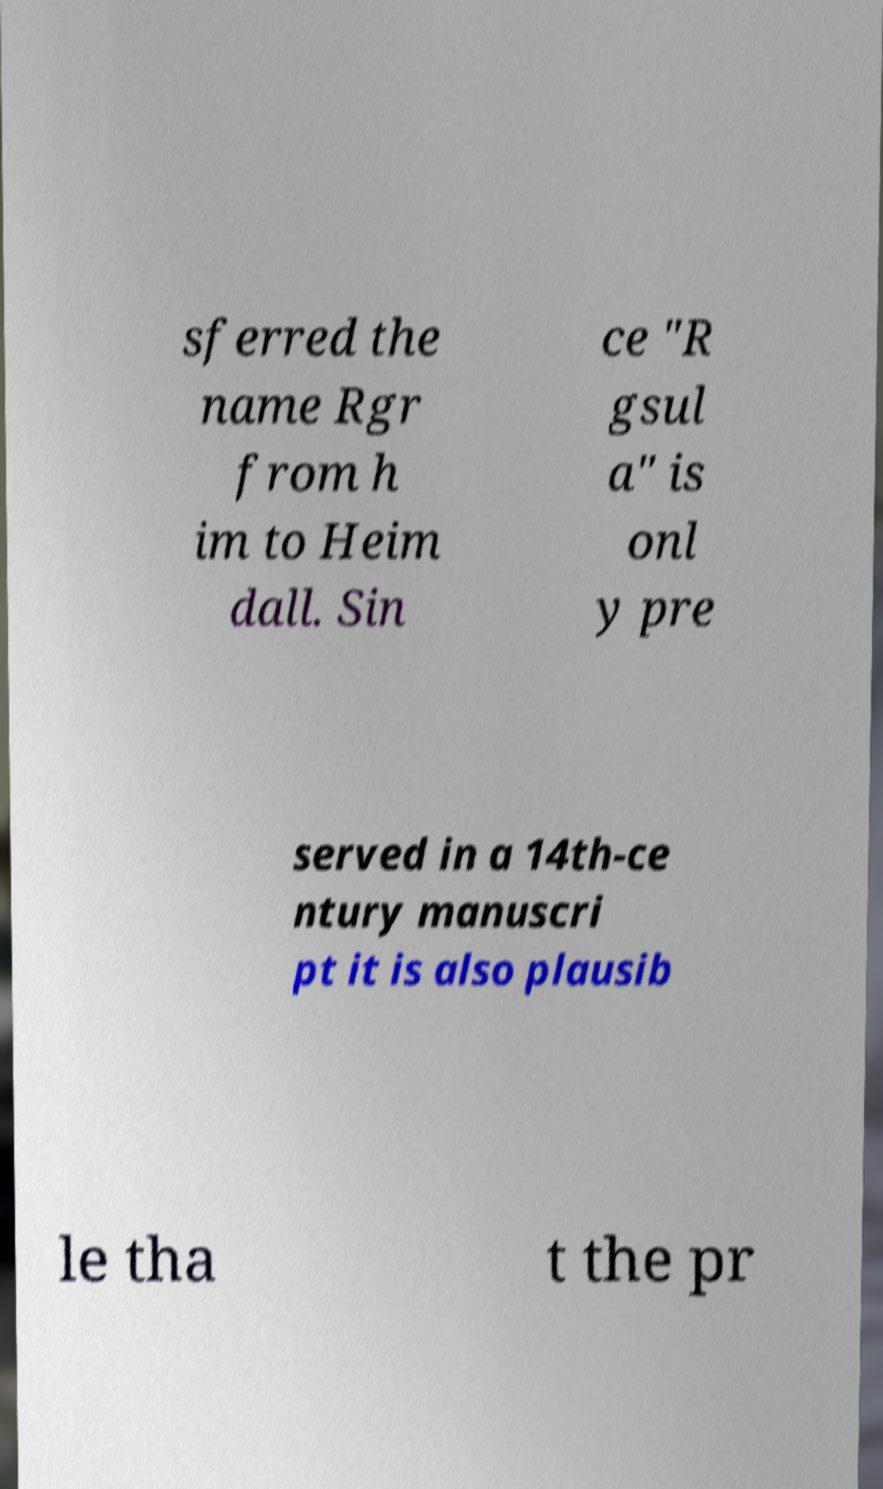Please read and relay the text visible in this image. What does it say? sferred the name Rgr from h im to Heim dall. Sin ce "R gsul a" is onl y pre served in a 14th-ce ntury manuscri pt it is also plausib le tha t the pr 